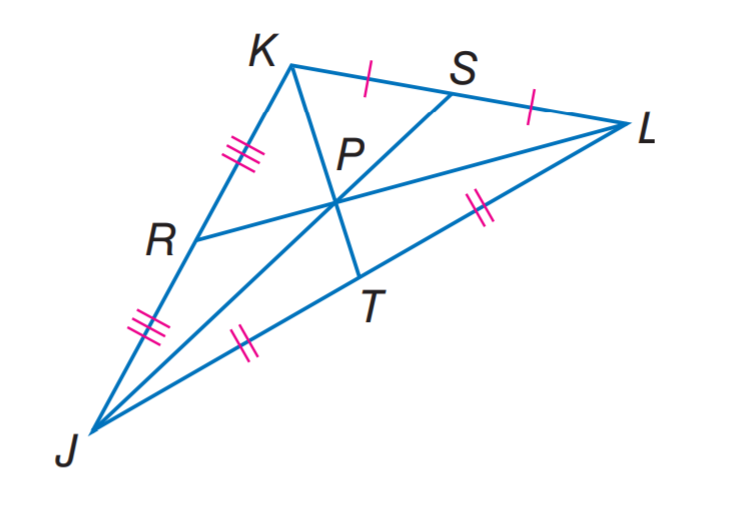Answer the mathemtical geometry problem and directly provide the correct option letter.
Question: R P = 3.5 and J P = 9. Find P L.
Choices: A: 3.5 B: 4.5 C: 7 D: 9 C 